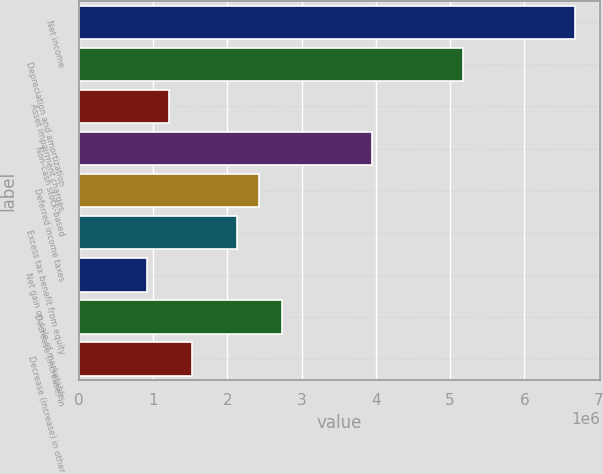Convert chart. <chart><loc_0><loc_0><loc_500><loc_500><bar_chart><fcel>Net income<fcel>Depreciation and amortization<fcel>Asset impairment charges<fcel>Non-cash stock-based<fcel>Deferred income taxes<fcel>Excess tax benefit from equity<fcel>Net gain on sale of marketable<fcel>Decrease (increase) in<fcel>Decrease (increase) in other<nl><fcel>6.6894e+06<fcel>5.16926e+06<fcel>1.21688e+06<fcel>3.95314e+06<fcel>2.433e+06<fcel>2.12897e+06<fcel>912854<fcel>2.73703e+06<fcel>1.52091e+06<nl></chart> 